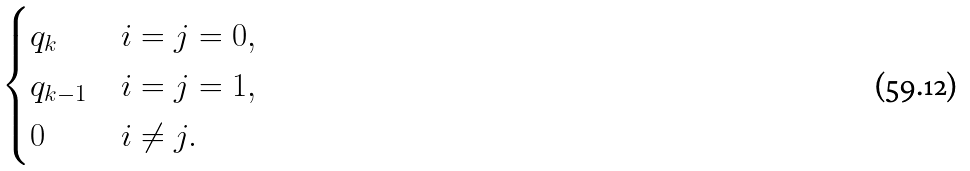Convert formula to latex. <formula><loc_0><loc_0><loc_500><loc_500>\begin{cases} q _ { k } & i = j = 0 , \\ q _ { k - 1 } & i = j = 1 , \\ 0 & i \neq j . \end{cases}</formula> 